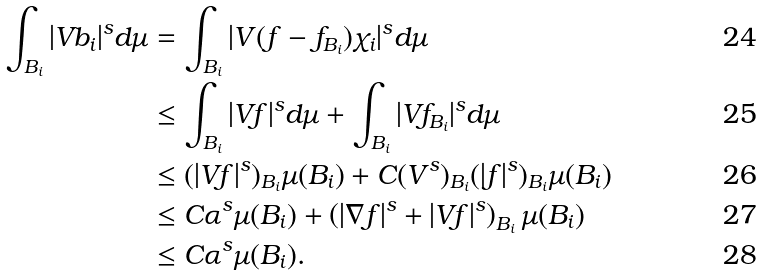<formula> <loc_0><loc_0><loc_500><loc_500>\int _ { B _ { i } } | V b _ { i } | ^ { s } d \mu & = \int _ { B _ { i } } | V ( f - f _ { B _ { i } } ) \chi _ { i } | ^ { s } d \mu \\ & \leq \int _ { B _ { i } } | V f | ^ { s } d \mu + \int _ { B _ { i } } | V f _ { B _ { i } } | ^ { s } d \mu \\ & \leq ( | V f | ^ { s } ) _ { B _ { i } } \mu ( B _ { i } ) + C ( V ^ { s } ) _ { B _ { i } } ( | f | ^ { s } ) _ { B _ { i } } \mu ( B _ { i } ) \\ & \leq C \alpha ^ { s } \mu ( B _ { i } ) + \left ( | \nabla f | ^ { s } + | V f | ^ { s } \right ) _ { B _ { i } } \mu ( B _ { i } ) \\ & \leq C \alpha ^ { s } \mu ( B _ { i } ) .</formula> 